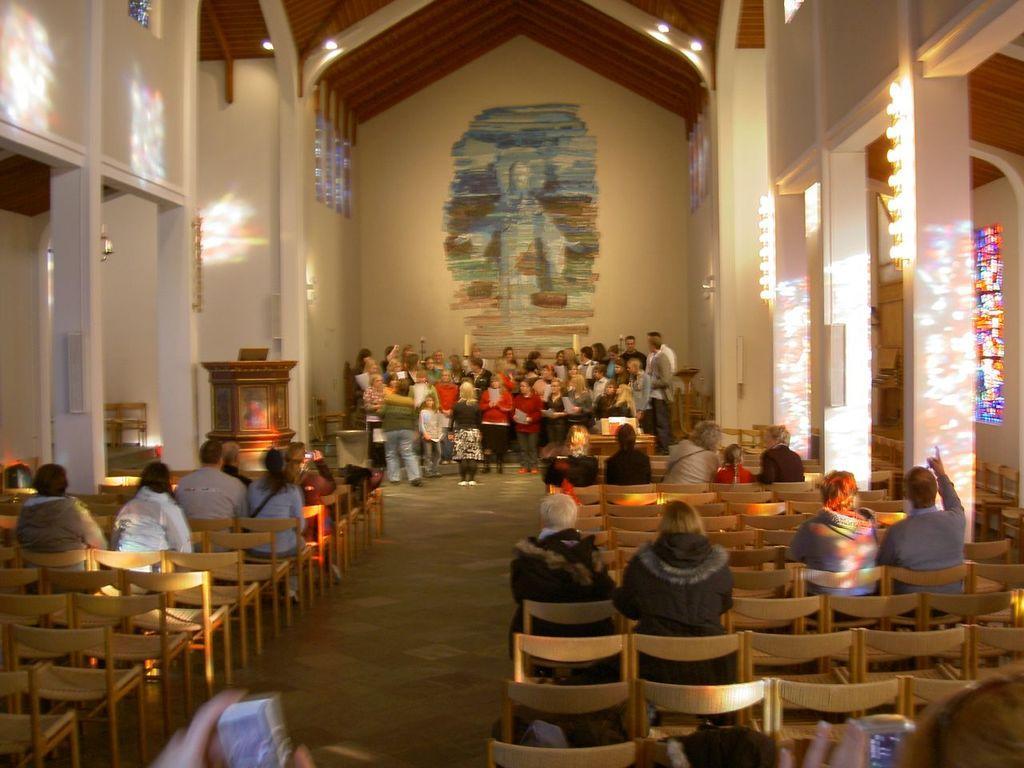How would you summarize this image in a sentence or two? There are chairs in a room. Few people are seated. Many people are standing at the back. There are pillars on the either sides the chairs and there are lights. 